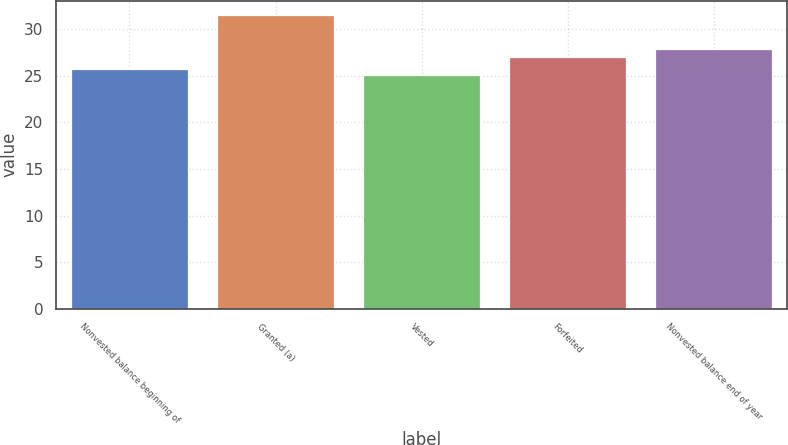<chart> <loc_0><loc_0><loc_500><loc_500><bar_chart><fcel>Nonvested balance beginning of<fcel>Granted (a)<fcel>Vested<fcel>Forfeited<fcel>Nonvested balance end of year<nl><fcel>25.76<fcel>31.5<fcel>25.12<fcel>27.01<fcel>27.88<nl></chart> 